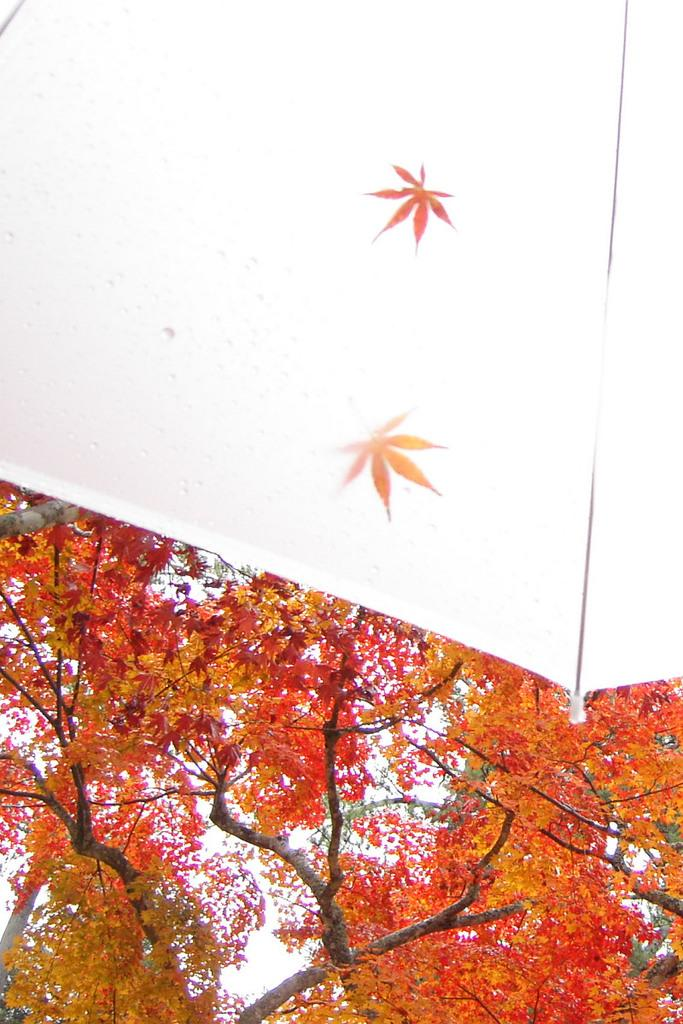What object is present in the image that can provide shelter from the rain? There is an umbrella in the image. What type of vegetation can be seen in the background of the image? There are trees in the background of the image. What part of the natural environment is visible in the background of the image? The sky is visible in the background of the image. How many deer can be seen grazing under the umbrella in the image? There are no deer present in the image; it only features an umbrella and the background. 